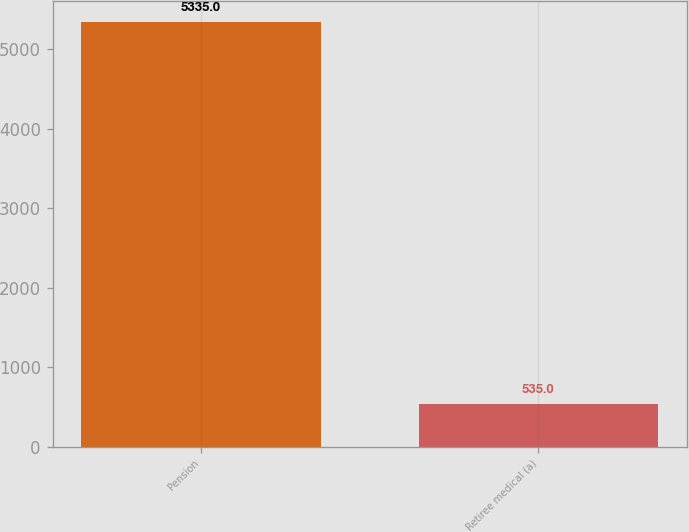Convert chart to OTSL. <chart><loc_0><loc_0><loc_500><loc_500><bar_chart><fcel>Pension<fcel>Retiree medical (a)<nl><fcel>5335<fcel>535<nl></chart> 